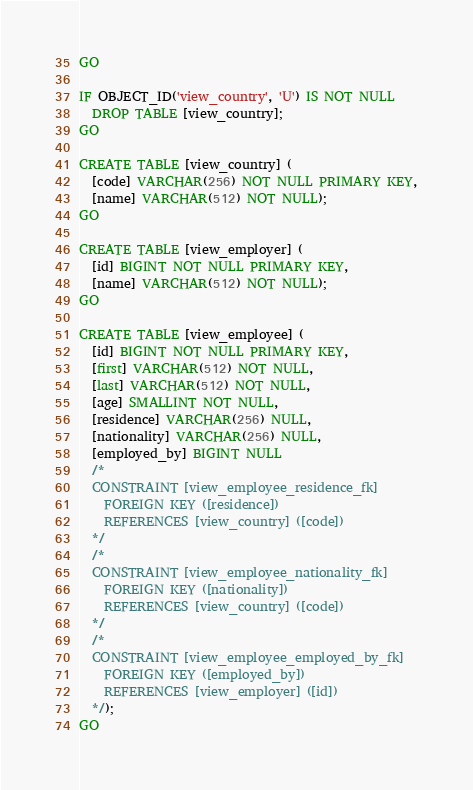<code> <loc_0><loc_0><loc_500><loc_500><_SQL_>GO

IF OBJECT_ID('view_country', 'U') IS NOT NULL
  DROP TABLE [view_country];
GO

CREATE TABLE [view_country] (
  [code] VARCHAR(256) NOT NULL PRIMARY KEY,
  [name] VARCHAR(512) NOT NULL);
GO

CREATE TABLE [view_employer] (
  [id] BIGINT NOT NULL PRIMARY KEY,
  [name] VARCHAR(512) NOT NULL);
GO

CREATE TABLE [view_employee] (
  [id] BIGINT NOT NULL PRIMARY KEY,
  [first] VARCHAR(512) NOT NULL,
  [last] VARCHAR(512) NOT NULL,
  [age] SMALLINT NOT NULL,
  [residence] VARCHAR(256) NULL,
  [nationality] VARCHAR(256) NULL,
  [employed_by] BIGINT NULL
  /*
  CONSTRAINT [view_employee_residence_fk]
    FOREIGN KEY ([residence])
    REFERENCES [view_country] ([code])
  */
  /*
  CONSTRAINT [view_employee_nationality_fk]
    FOREIGN KEY ([nationality])
    REFERENCES [view_country] ([code])
  */
  /*
  CONSTRAINT [view_employee_employed_by_fk]
    FOREIGN KEY ([employed_by])
    REFERENCES [view_employer] ([id])
  */);
GO

</code> 